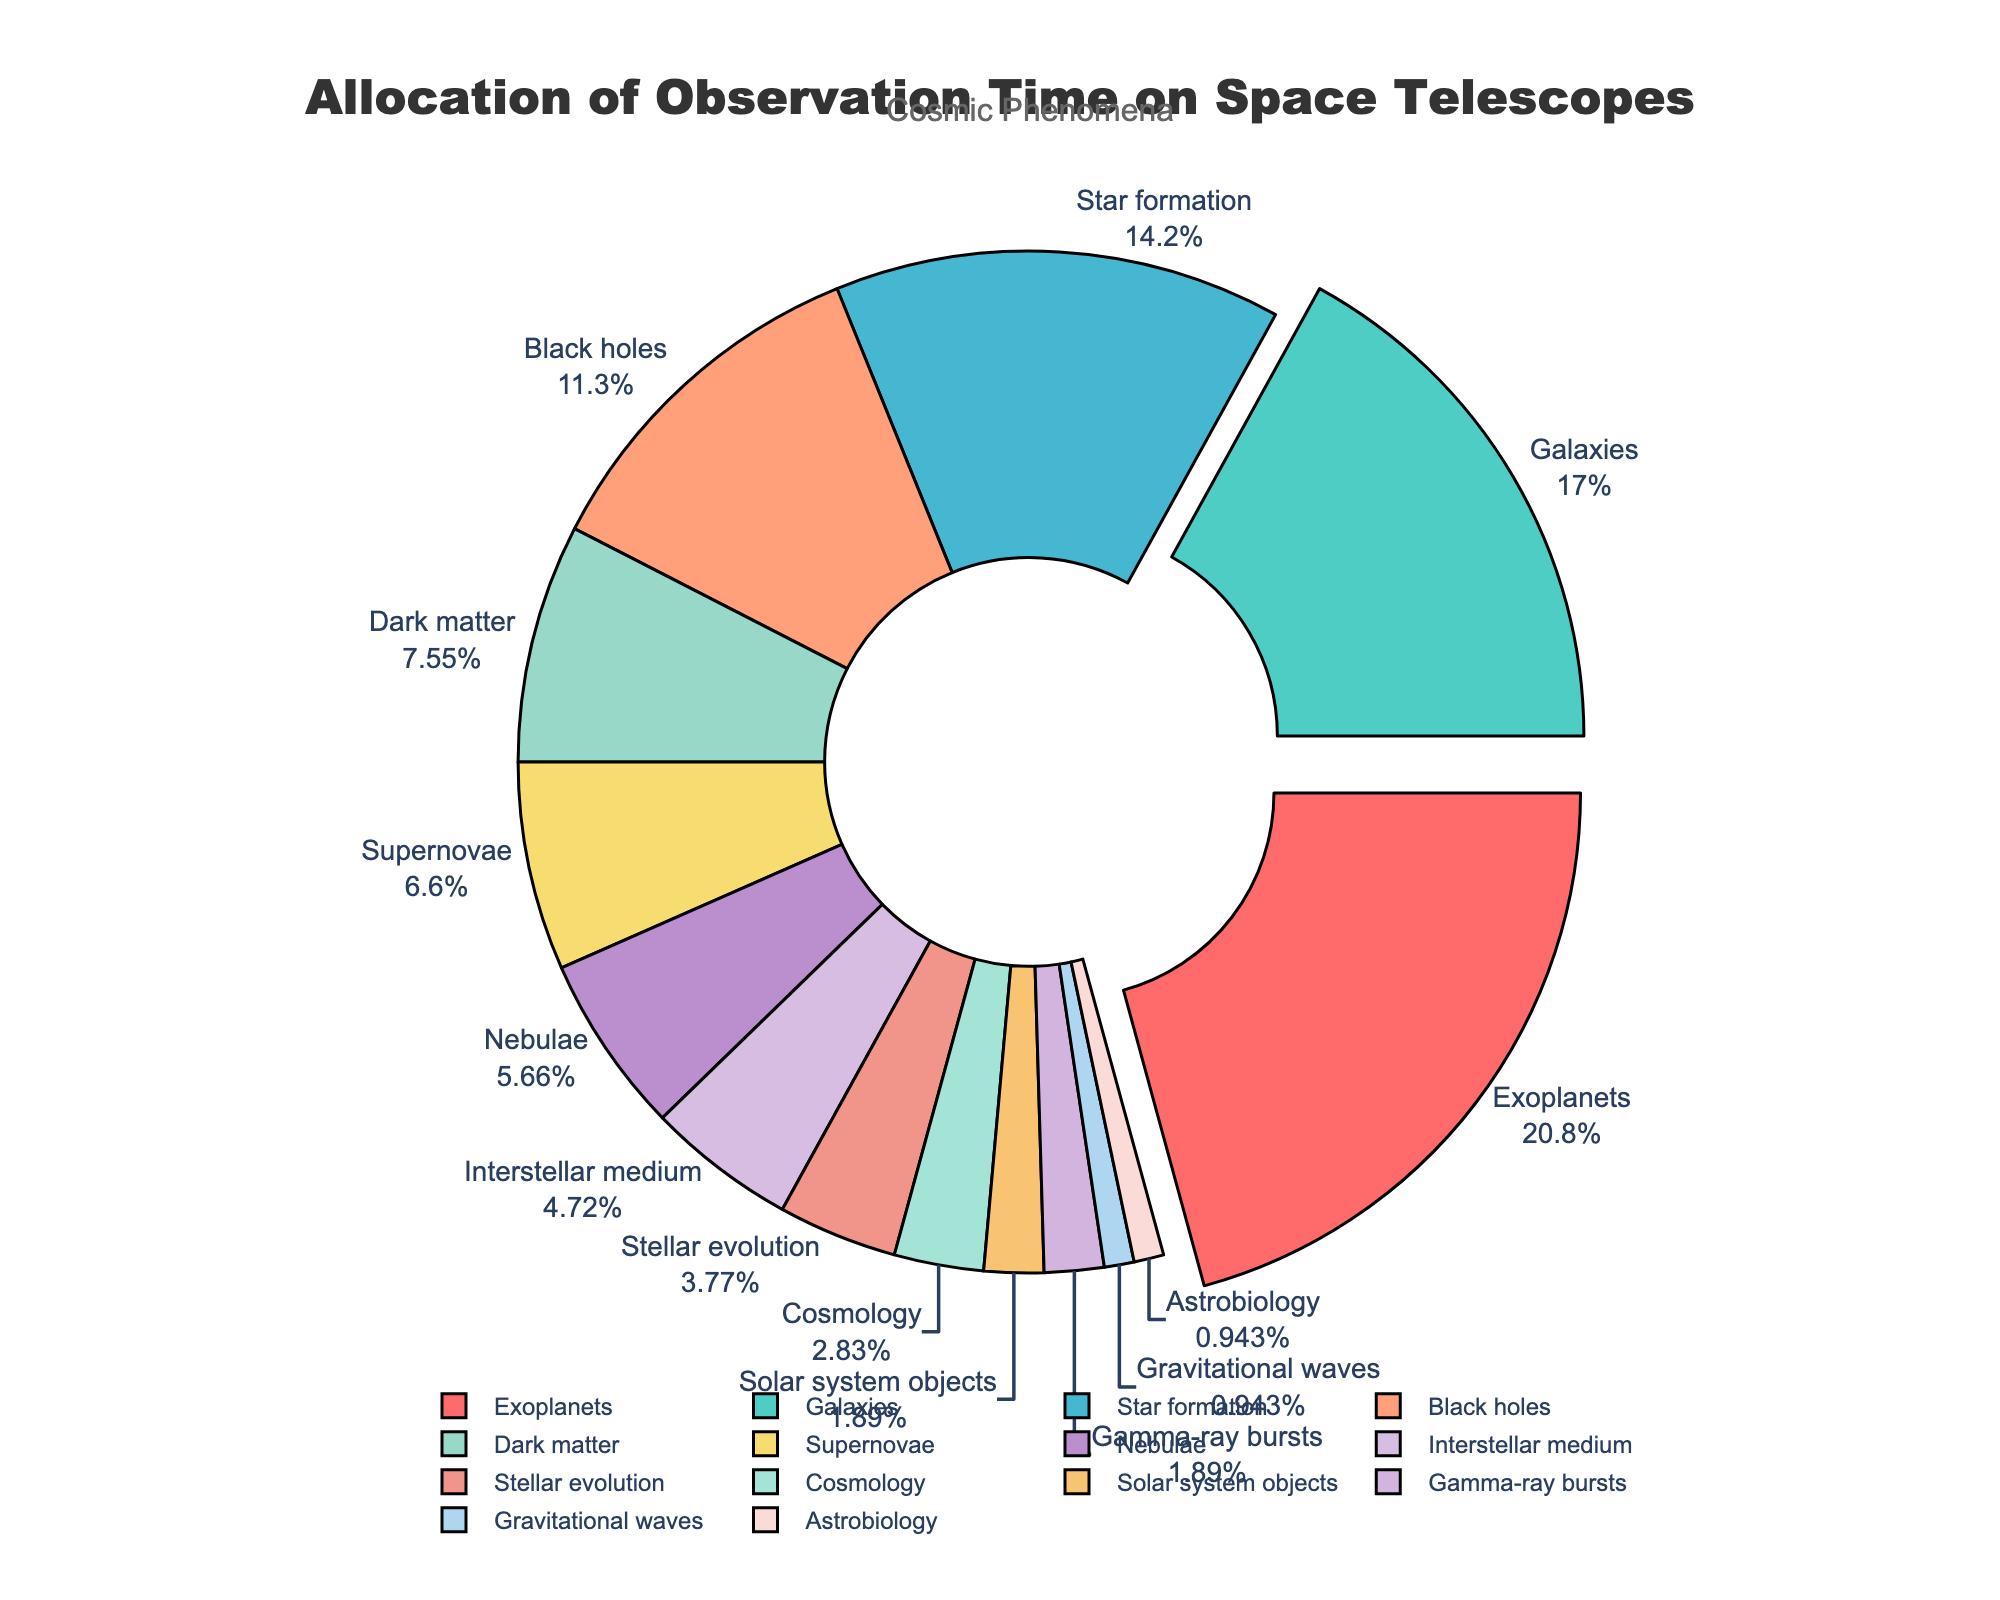How much total observation time is allocated to Exoplanets, Galaxies, and Star formation combined? Sum the percentages allocated to Exoplanets (22%), Galaxies (18%), and Star formation (15%): 22 + 18 + 15 = 55
Answer: 55% Which phenomenon has the highest allocation of observation time? Identify the phenomenon with the largest percentage label: Exoplanets at 22%
Answer: Exoplanets Which phenomena have less than 5% of observation time allocated? Identify all phenomena with a percentage label less than 5%: Stellar evolution (4%), Cosmology (3%), Solar system objects (2%), Gamma-ray bursts (2%), Gravitational waves (1%), Astrobiology (1%)
Answer: Stellar evolution, Cosmology, Solar system objects, Gamma-ray bursts, Gravitational waves, Astrobiology By how much does the observation time for Black holes exceed that of Dark matter? Subtract the percentage allocated to Dark matter (8%) from the percentage allocated to Black holes (12%): 12 - 8 = 4
Answer: 4% Which phenomenon is represented by the color green? Identify the phenomenon associated with the color green: Dark matter (8%) is represented by green
Answer: Dark matter Determine the average allocation of observation time for Nebulae, Interstellar medium, and Stellar evolution. Sum the percentages of Nebulae (6%), Interstellar medium (5%), and Stellar evolution (4%) and divide by 3: (6 + 5 + 4) / 3 = 15 / 3 = 5
Answer: 5% Is the allocation of observation time for Black holes greater than for Supernovae and Nebulae combined? Compare the percentage of Black holes (12%) to the combined percentage of Supernovae (7%) and Nebulae (6%): 7 + 6 = 13. Since 12 < 13, Black holes have less
Answer: No What proportion of observation time is allocated to cosmic phenomena related to stellar and galactic activities (Star formation, Stellar evolution, Galaxies)? Sum the percentages of Star formation (15%), Stellar evolution (4%), and Galaxies (18%): 15 + 4 + 18 = 37
Answer: 37% Which phenomena have the same allocation of observation time? Identify phenomena with identical percentage labels: Solar system objects (2%) and Gamma-ray bursts (2%), Gravitational waves (1%) and Astrobiology (1%)
Answer: Solar system objects and Gamma-ray bursts; Gravitational waves and Astrobiology How does the observation time for Galaxies compare to the total time for Solar system objects, Gamma-ray bursts, Gravitational waves, and Astrobiology? Compare the percentage of Galaxies (18%) with the combined total of Solar system objects (2%), Gamma-ray bursts (2%), Gravitational waves (1%), and Astrobiology (1%): 2 + 2 + 1 + 1 = 6. Since 18 > 6, Galaxies have more
Answer: Galaxies have more 